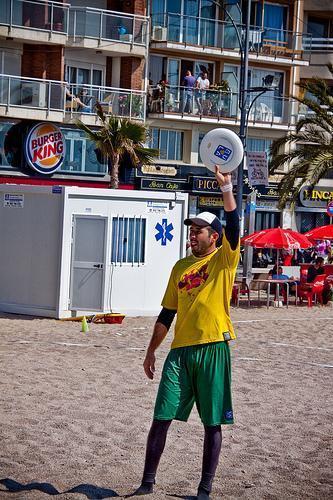How many people in this image are holding up a frisbee?
Give a very brief answer. 1. 